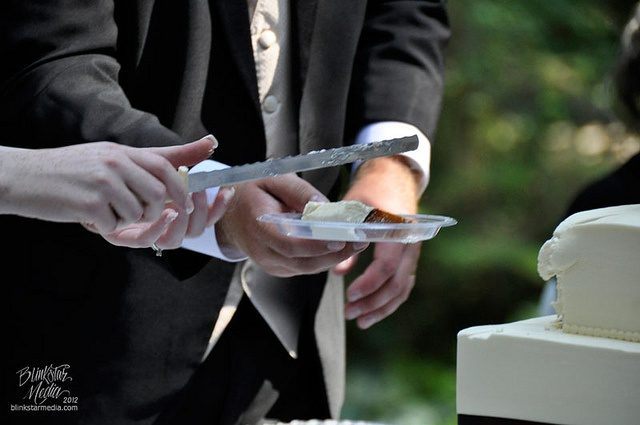Describe the objects in this image and their specific colors. I can see people in black, gray, darkgray, and white tones, cake in black, darkgray, gray, and lightgray tones, people in black, gray, and darkgray tones, people in black, gray, and darkgreen tones, and knife in black, gray, and darkgray tones in this image. 